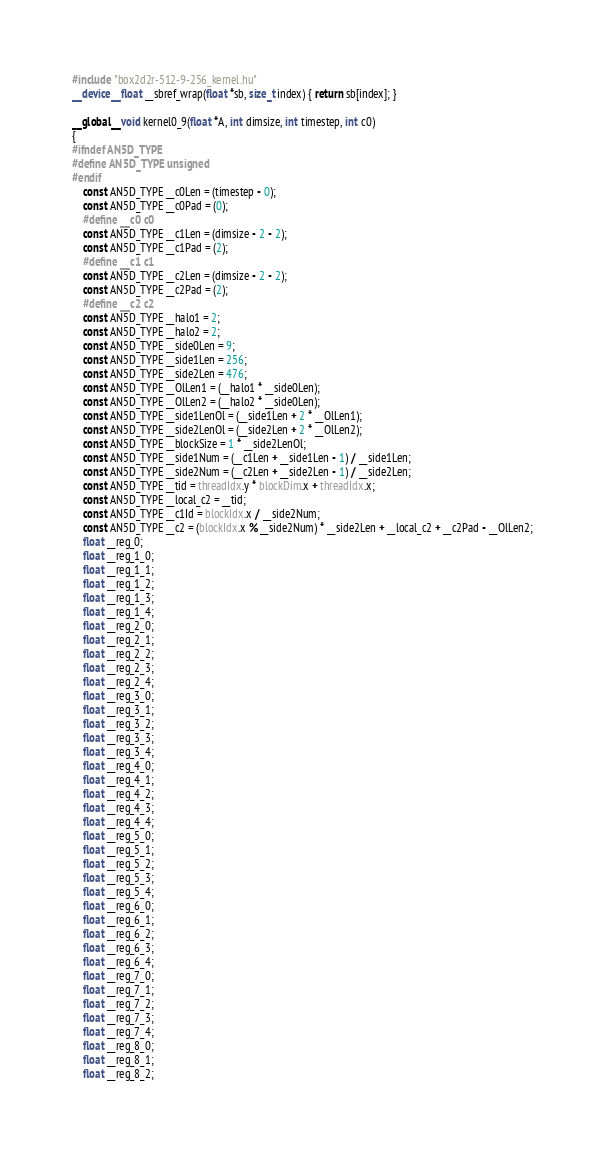Convert code to text. <code><loc_0><loc_0><loc_500><loc_500><_Cuda_>#include "box2d2r-512-9-256_kernel.hu"
__device__ float __sbref_wrap(float *sb, size_t index) { return sb[index]; }

__global__ void kernel0_9(float *A, int dimsize, int timestep, int c0)
{
#ifndef AN5D_TYPE
#define AN5D_TYPE unsigned
#endif
    const AN5D_TYPE __c0Len = (timestep - 0);
    const AN5D_TYPE __c0Pad = (0);
    #define __c0 c0
    const AN5D_TYPE __c1Len = (dimsize - 2 - 2);
    const AN5D_TYPE __c1Pad = (2);
    #define __c1 c1
    const AN5D_TYPE __c2Len = (dimsize - 2 - 2);
    const AN5D_TYPE __c2Pad = (2);
    #define __c2 c2
    const AN5D_TYPE __halo1 = 2;
    const AN5D_TYPE __halo2 = 2;
    const AN5D_TYPE __side0Len = 9;
    const AN5D_TYPE __side1Len = 256;
    const AN5D_TYPE __side2Len = 476;
    const AN5D_TYPE __OlLen1 = (__halo1 * __side0Len);
    const AN5D_TYPE __OlLen2 = (__halo2 * __side0Len);
    const AN5D_TYPE __side1LenOl = (__side1Len + 2 * __OlLen1);
    const AN5D_TYPE __side2LenOl = (__side2Len + 2 * __OlLen2);
    const AN5D_TYPE __blockSize = 1 * __side2LenOl;
    const AN5D_TYPE __side1Num = (__c1Len + __side1Len - 1) / __side1Len;
    const AN5D_TYPE __side2Num = (__c2Len + __side2Len - 1) / __side2Len;
    const AN5D_TYPE __tid = threadIdx.y * blockDim.x + threadIdx.x;
    const AN5D_TYPE __local_c2 = __tid;
    const AN5D_TYPE __c1Id = blockIdx.x / __side2Num;
    const AN5D_TYPE __c2 = (blockIdx.x % __side2Num) * __side2Len + __local_c2 + __c2Pad - __OlLen2;
    float __reg_0;
    float __reg_1_0;
    float __reg_1_1;
    float __reg_1_2;
    float __reg_1_3;
    float __reg_1_4;
    float __reg_2_0;
    float __reg_2_1;
    float __reg_2_2;
    float __reg_2_3;
    float __reg_2_4;
    float __reg_3_0;
    float __reg_3_1;
    float __reg_3_2;
    float __reg_3_3;
    float __reg_3_4;
    float __reg_4_0;
    float __reg_4_1;
    float __reg_4_2;
    float __reg_4_3;
    float __reg_4_4;
    float __reg_5_0;
    float __reg_5_1;
    float __reg_5_2;
    float __reg_5_3;
    float __reg_5_4;
    float __reg_6_0;
    float __reg_6_1;
    float __reg_6_2;
    float __reg_6_3;
    float __reg_6_4;
    float __reg_7_0;
    float __reg_7_1;
    float __reg_7_2;
    float __reg_7_3;
    float __reg_7_4;
    float __reg_8_0;
    float __reg_8_1;
    float __reg_8_2;</code> 